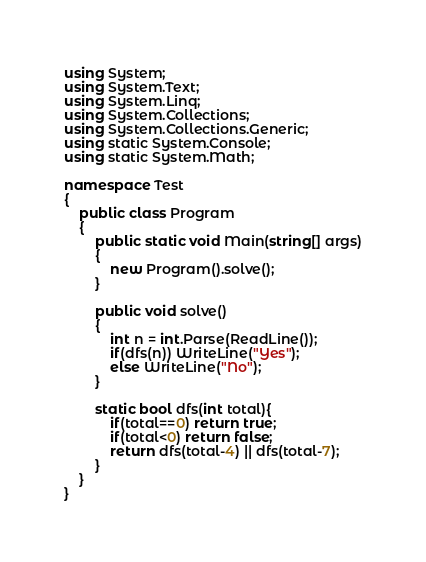<code> <loc_0><loc_0><loc_500><loc_500><_C#_>using System;
using System.Text;
using System.Linq;
using System.Collections;
using System.Collections.Generic;
using static System.Console;
using static System.Math;

namespace Test
{
    public class Program
    {
        public static void Main(string[] args)
        {
            new Program().solve();
        }

        public void solve()
        {
            int n = int.Parse(ReadLine());
            if(dfs(n)) WriteLine("Yes");
            else WriteLine("No");
        }

        static bool dfs(int total){
            if(total==0) return true;
            if(total<0) return false;
            return dfs(total-4) || dfs(total-7);
        }
    }
}</code> 